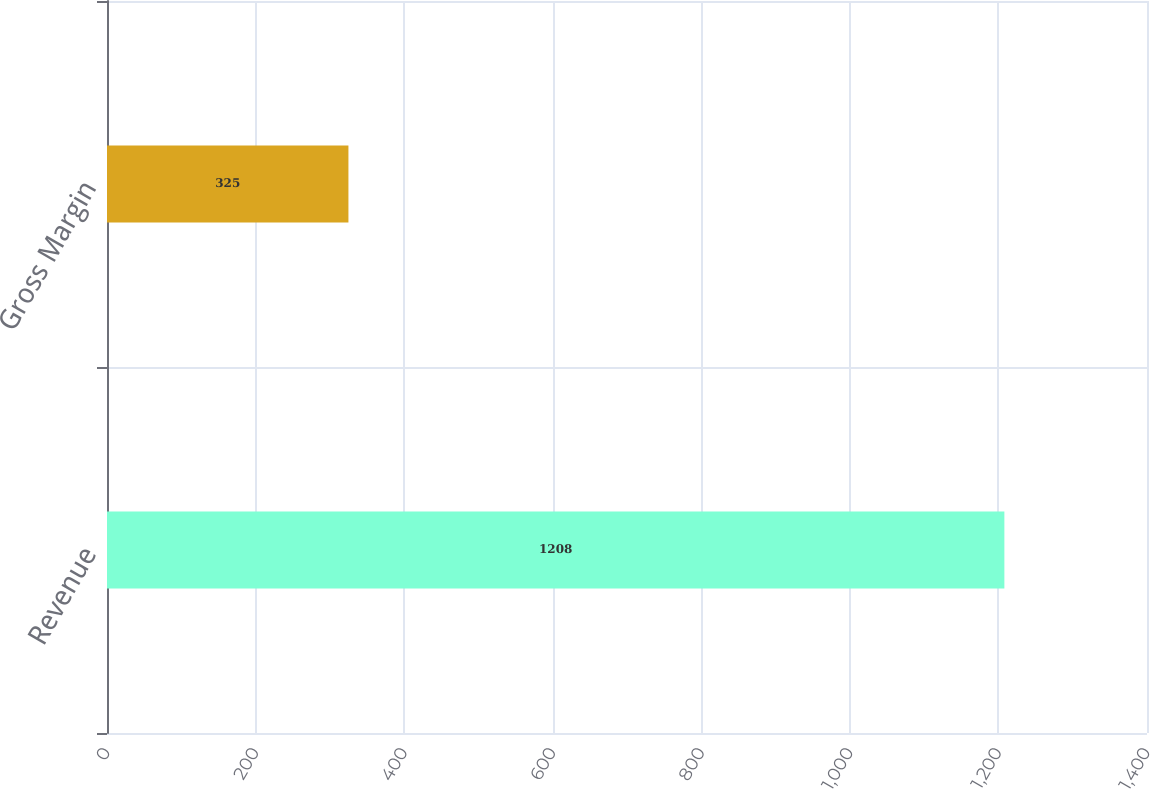Convert chart to OTSL. <chart><loc_0><loc_0><loc_500><loc_500><bar_chart><fcel>Revenue<fcel>Gross Margin<nl><fcel>1208<fcel>325<nl></chart> 